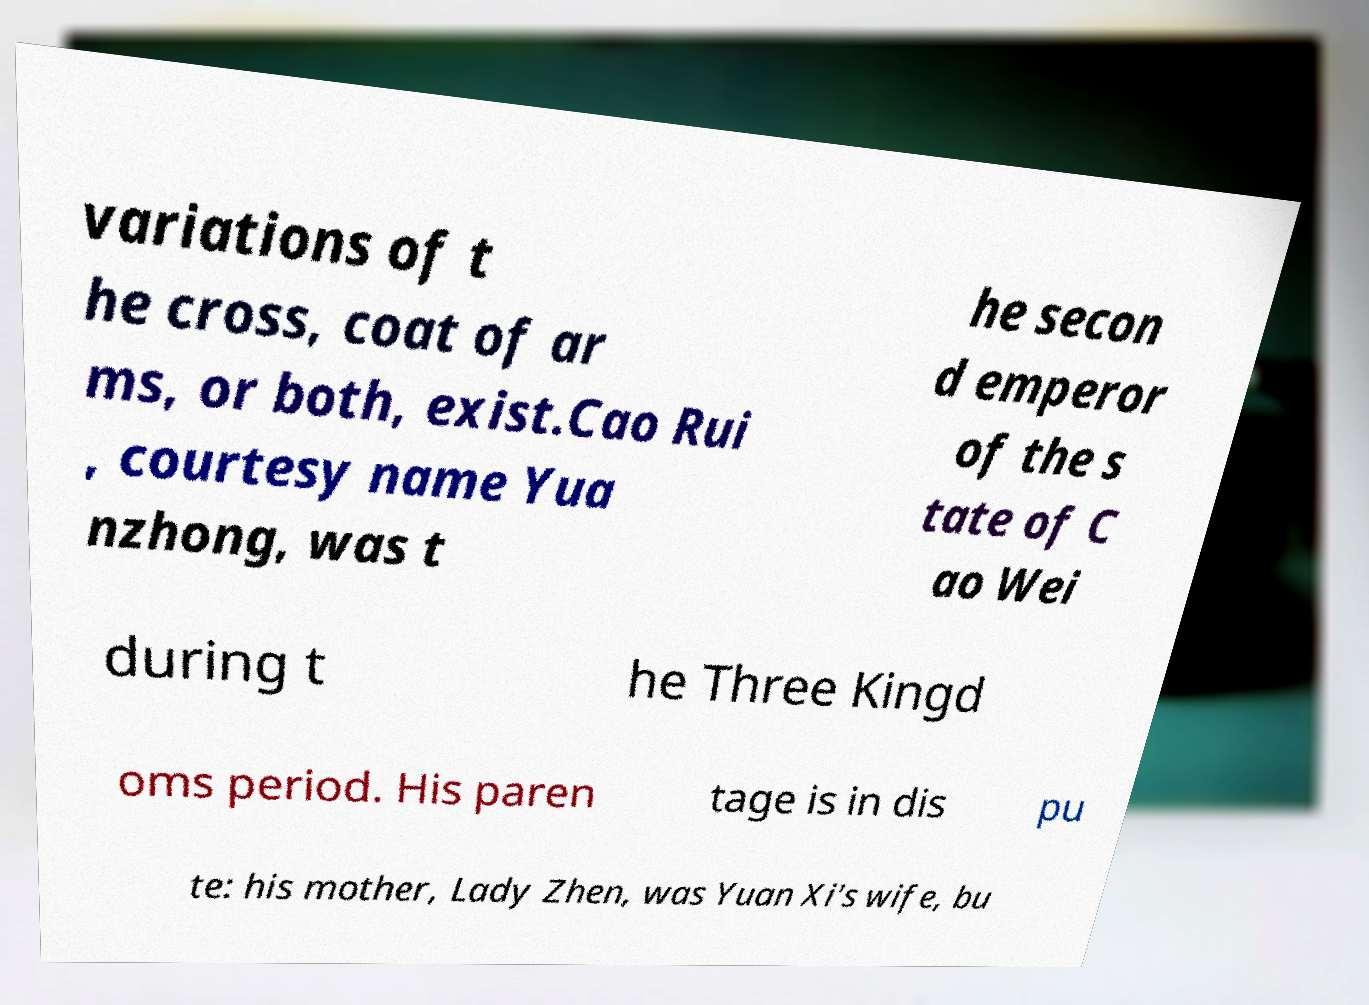What messages or text are displayed in this image? I need them in a readable, typed format. variations of t he cross, coat of ar ms, or both, exist.Cao Rui , courtesy name Yua nzhong, was t he secon d emperor of the s tate of C ao Wei during t he Three Kingd oms period. His paren tage is in dis pu te: his mother, Lady Zhen, was Yuan Xi's wife, bu 